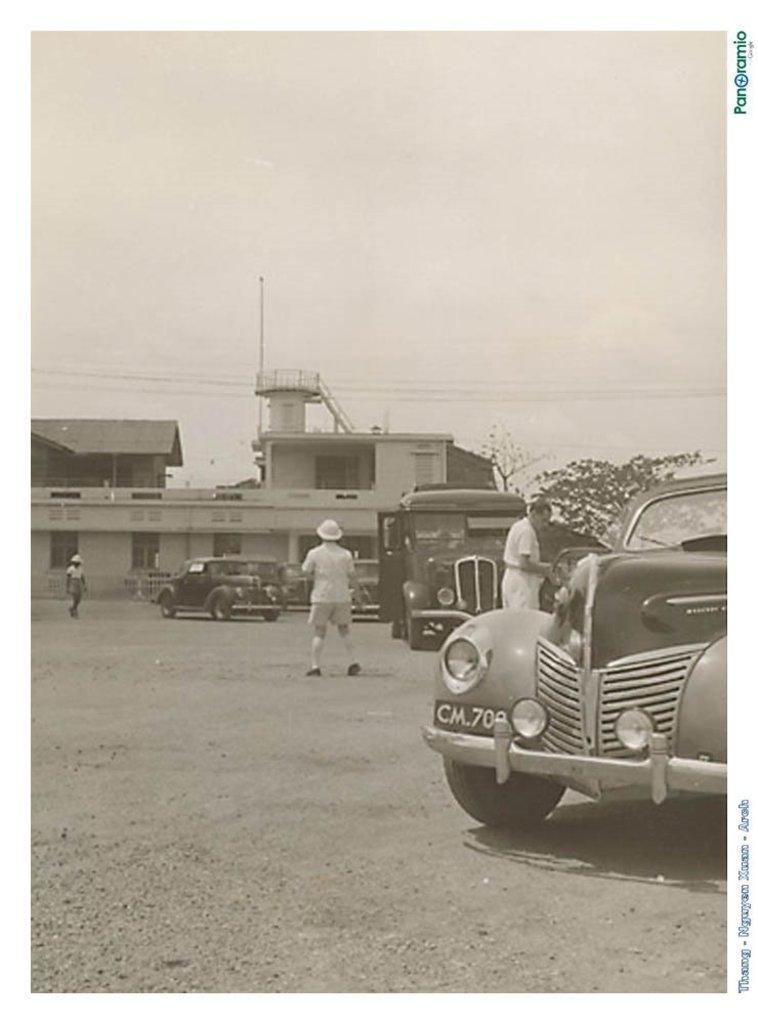What types of objects are present in the image? There are vehicles and people in the image. What can be seen in the background of the image? There is a building, a pole, stairs, and trees in the background of the image. Are there any additional features in the image? Yes, there are wires in the image. What is the color scheme of the image? The image is in black and white. How many geese are present in the image? There are no geese present in the image. What is the wealth of the people in the image? The image does not provide any information about the wealth of the people. 